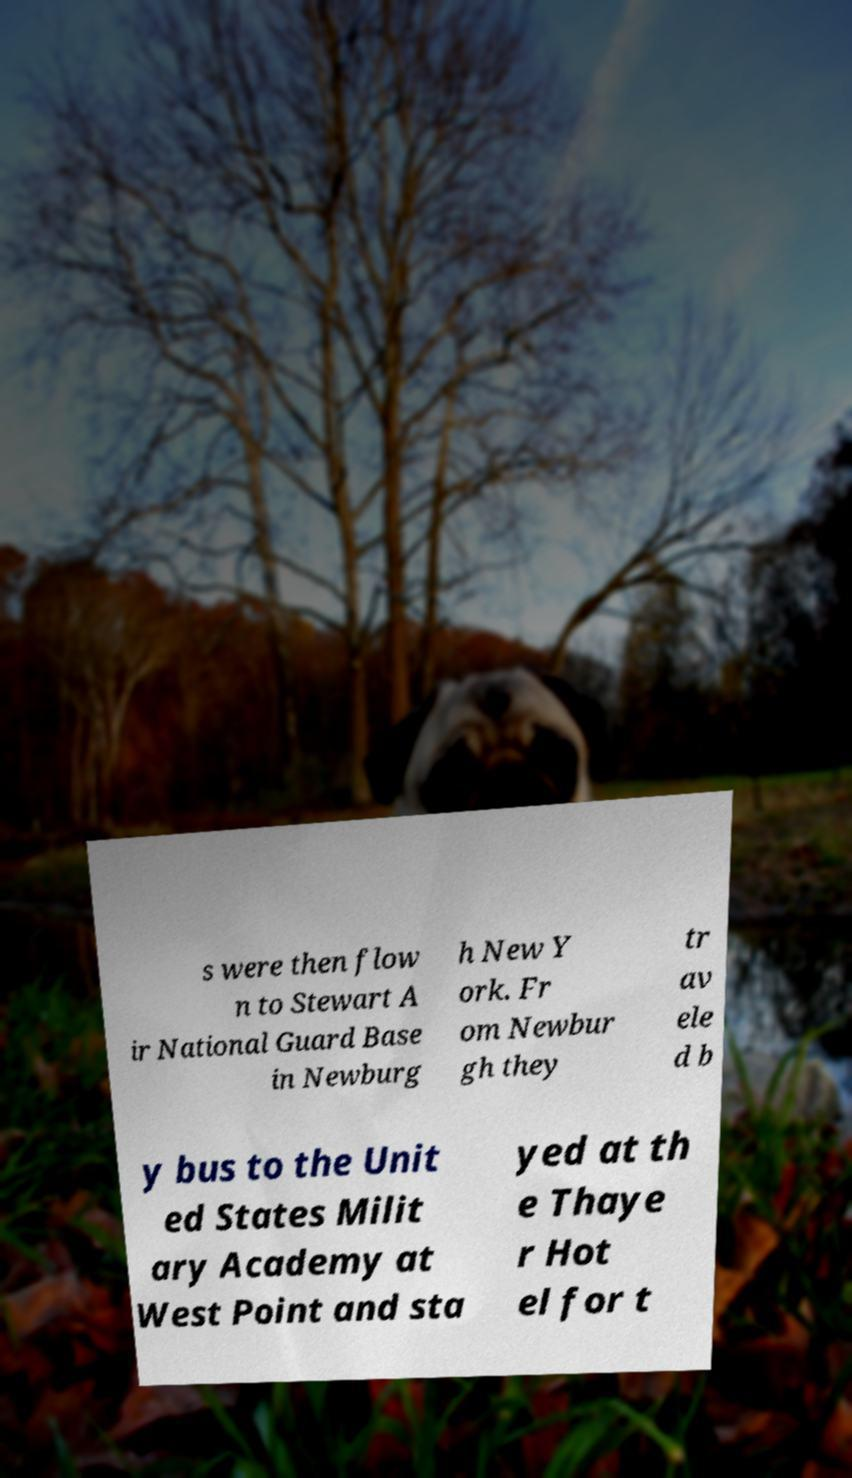Could you assist in decoding the text presented in this image and type it out clearly? s were then flow n to Stewart A ir National Guard Base in Newburg h New Y ork. Fr om Newbur gh they tr av ele d b y bus to the Unit ed States Milit ary Academy at West Point and sta yed at th e Thaye r Hot el for t 